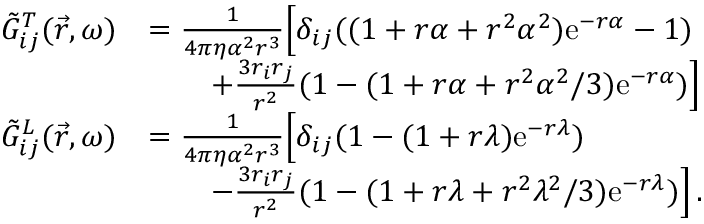Convert formula to latex. <formula><loc_0><loc_0><loc_500><loc_500>\begin{array} { r l } { \tilde { G } _ { i j } ^ { T } ( \vec { r } , \omega ) } & { = \frac { 1 } { 4 \pi \eta \alpha ^ { 2 } r ^ { 3 } } \left [ \delta _ { i j } ( ( 1 + r \alpha + r ^ { 2 } \alpha ^ { 2 } ) e ^ { - r \alpha } - 1 ) } \\ & { \quad + \frac { 3 r _ { i } r _ { j } } { r ^ { 2 } } ( 1 - ( 1 + r \alpha + r ^ { 2 } \alpha ^ { 2 } / 3 ) e ^ { - r \alpha } ) \right ] } \\ { \tilde { G } _ { i j } ^ { L } ( \vec { r } , \omega ) } & { = \frac { 1 } { 4 \pi \eta \alpha ^ { 2 } r ^ { 3 } } \left [ \delta _ { i j } ( 1 - ( 1 + r \lambda ) e ^ { - r \lambda } ) } \\ & { \quad - \frac { 3 r _ { i } r _ { j } } { r ^ { 2 } } ( 1 - ( 1 + r \lambda + r ^ { 2 } \lambda ^ { 2 } / 3 ) e ^ { - r \lambda } ) \right ] \, . } \end{array}</formula> 